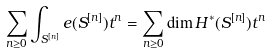Convert formula to latex. <formula><loc_0><loc_0><loc_500><loc_500>\sum _ { n \geq 0 } \int _ { S ^ { [ n ] } } e ( S ^ { [ n ] } ) t ^ { n } = \sum _ { n \geq 0 } \dim H ^ { * } ( S ^ { [ n ] } ) t ^ { n }</formula> 